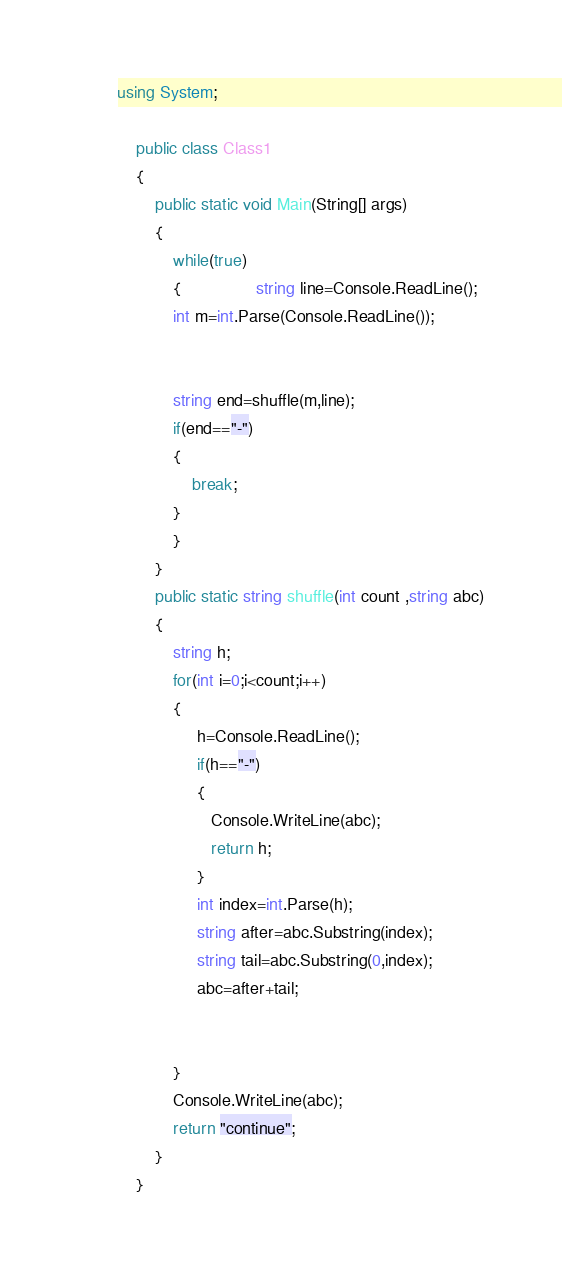Convert code to text. <code><loc_0><loc_0><loc_500><loc_500><_C#_>using System;

	public class Class1
	{
		public static void Main(String[] args)
		{   
			while(true)
			{				string line=Console.ReadLine();
			int m=int.Parse(Console.ReadLine());
			
			
			string end=shuffle(m,line);
			if(end=="-")
			{
				break;
			}
			}
		}
		public static string shuffle(int count ,string abc)
		{	
			string h;
			for(int i=0;i<count;i++)
			{
				 h=Console.ReadLine();
				 if(h=="-")
				 {
				 	Console.WriteLine(abc);
				 	return h;
				 }
				 int index=int.Parse(h);
				 string after=abc.Substring(index);
				 string tail=abc.Substring(0,index);
				 abc=after+tail;
				 
				 
			}
			Console.WriteLine(abc);
			return "continue";
		}
	}</code> 